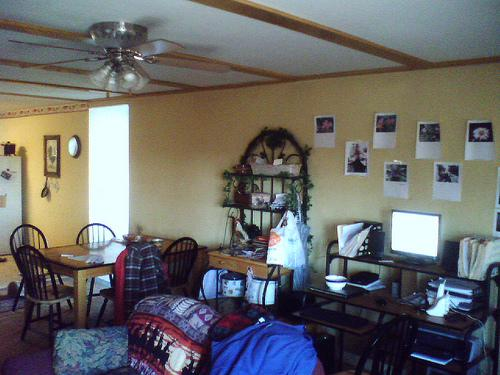Question: where was the photo taken?
Choices:
A. In the living room.
B. In the bathroom.
C. In the car.
D. In the pool.
Answer with the letter. Answer: A Question: who is on the photo?
Choices:
A. 1 small child.
B. A group of teens.
C. Nobody.
D. Insects.
Answer with the letter. Answer: C Question: what is on?
Choices:
A. The TV.
B. The laptop.
C. The computer.
D. A radio.
Answer with the letter. Answer: C Question: why is the photo clear?
Choices:
A. It's during the day.
B. It's sunny.
C. Not a cloud in the sky.
D. Great camera lens.
Answer with the letter. Answer: A Question: how is the photo?
Choices:
A. Clear.
B. Blurry.
C. A finger in the way.
D. Torn.
Answer with the letter. Answer: A 